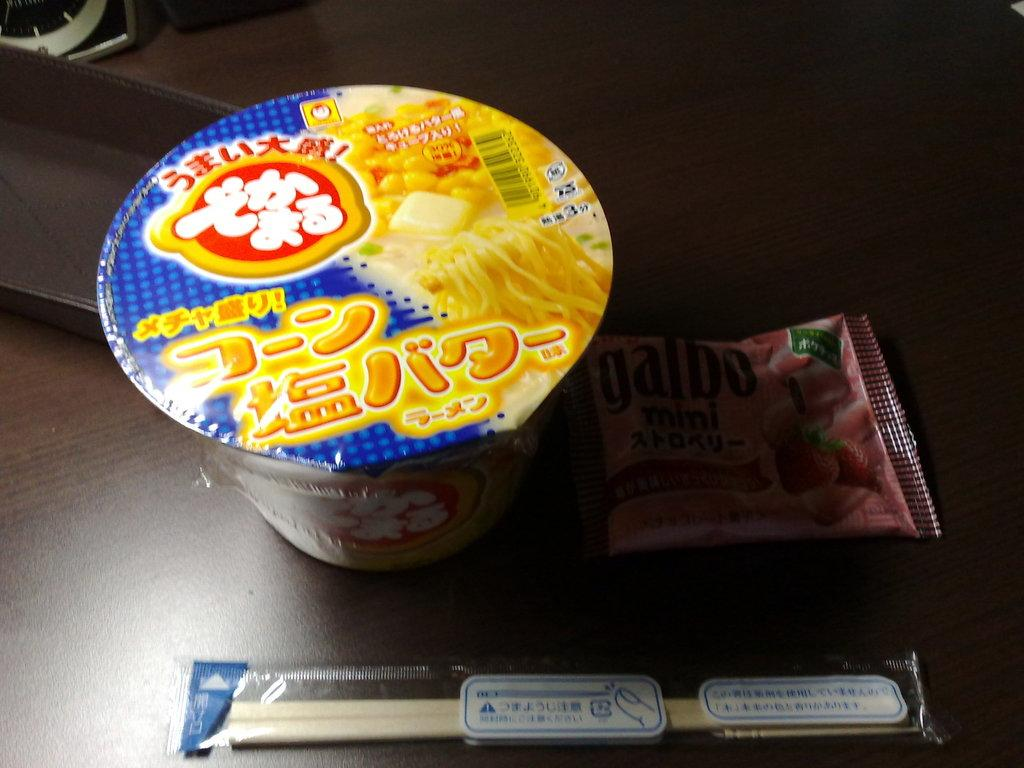What type of food is visible in the image? There is convenience food in the image. What objects are present in the image besides the food? There are two sticks in the image. What type of toy can be seen in the image? There is no toy present in the image; it only features convenience food and two sticks. 